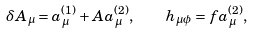<formula> <loc_0><loc_0><loc_500><loc_500>\delta A _ { \mu } = a ^ { ( 1 ) } _ { \mu } + A a ^ { ( 2 ) } _ { \mu } , \quad h _ { \mu \phi } = f a ^ { ( 2 ) } _ { \mu } ,</formula> 